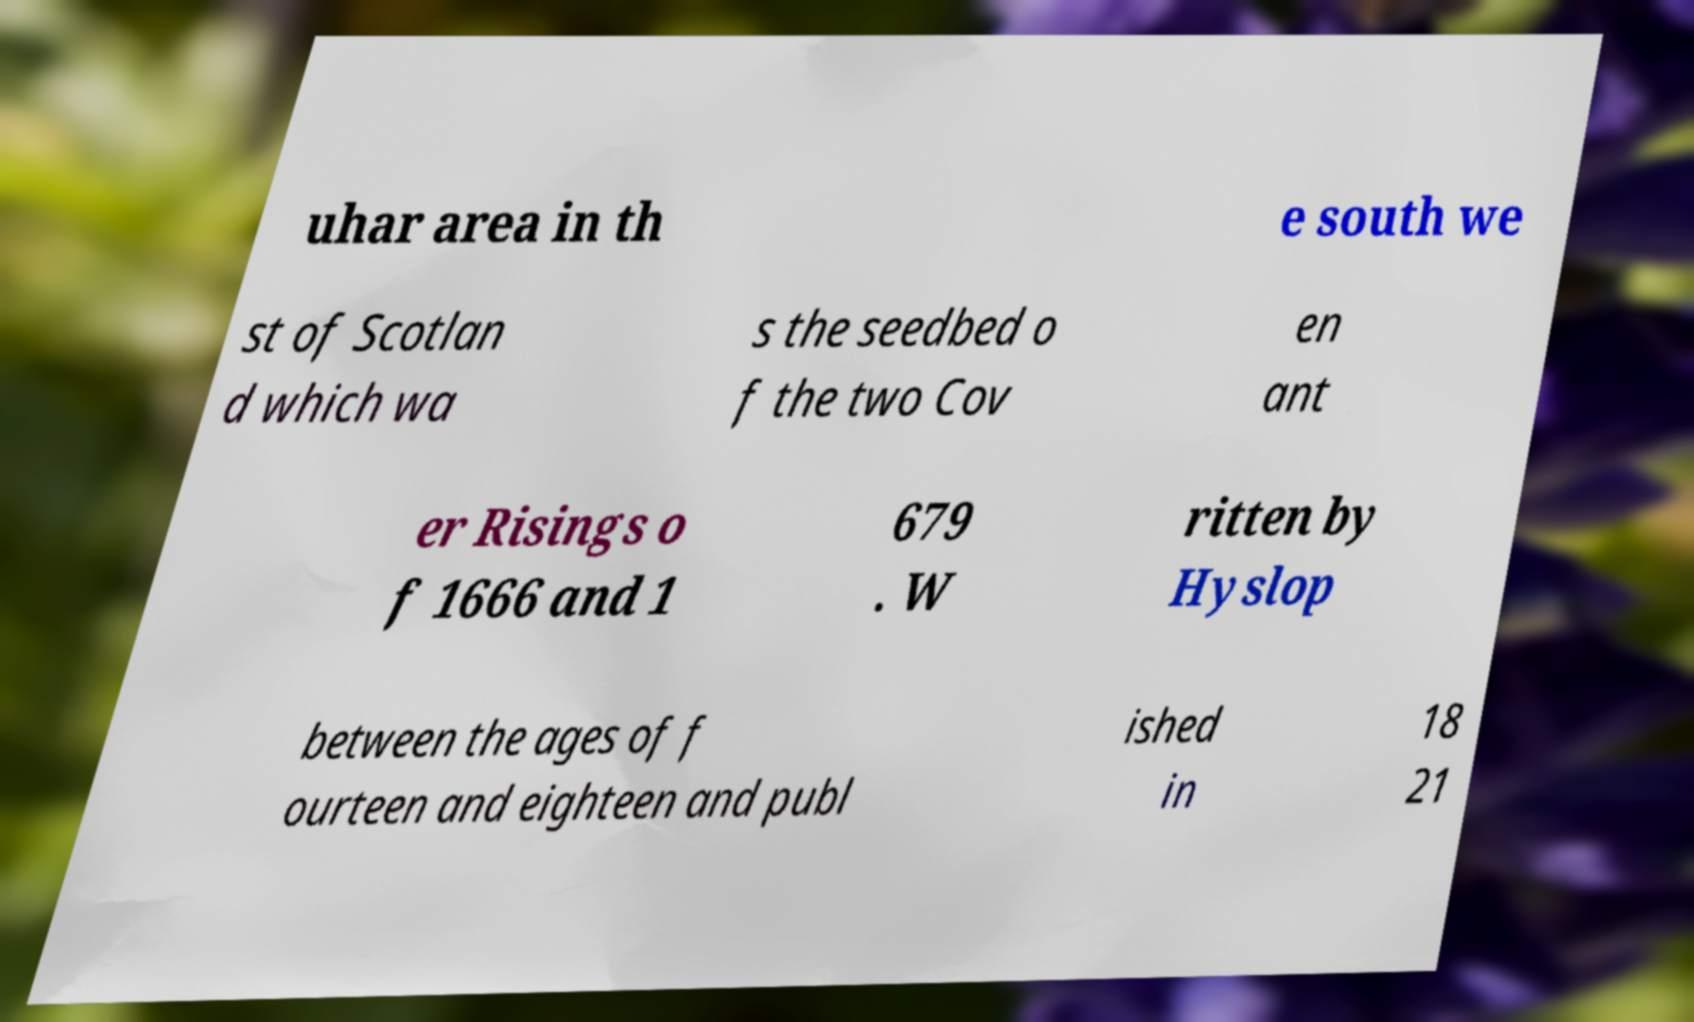For documentation purposes, I need the text within this image transcribed. Could you provide that? uhar area in th e south we st of Scotlan d which wa s the seedbed o f the two Cov en ant er Risings o f 1666 and 1 679 . W ritten by Hyslop between the ages of f ourteen and eighteen and publ ished in 18 21 